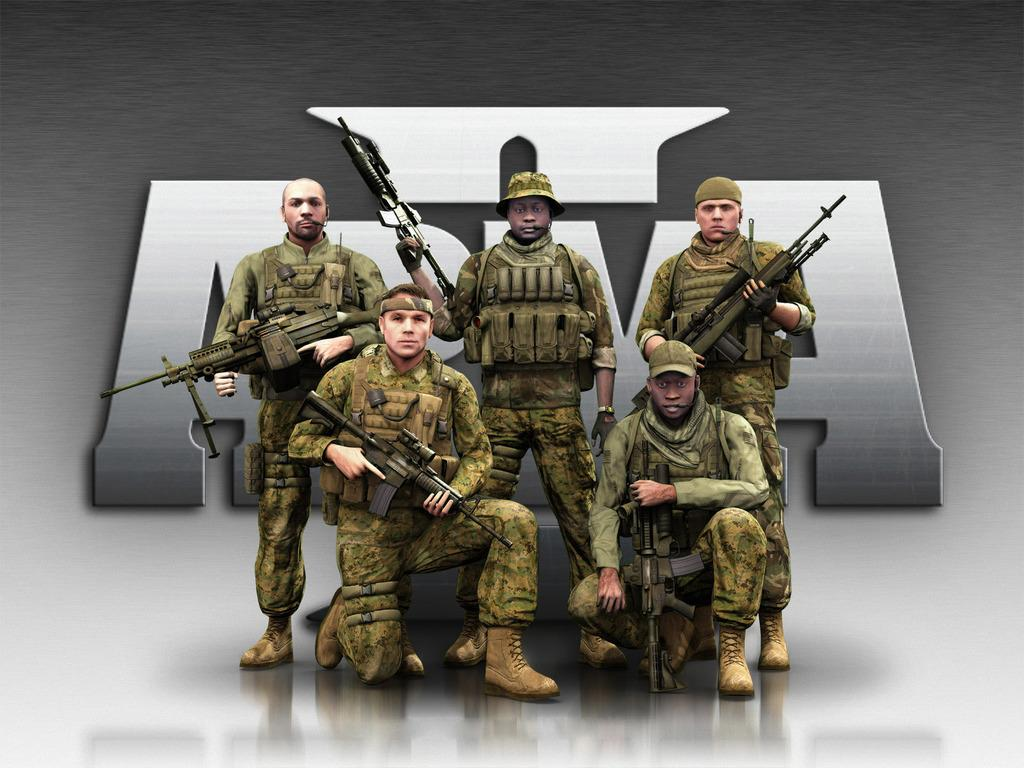What are the people in the image doing? Some people are standing, and some are sitting in the image. What are the people wearing? The people are wearing uniforms. What objects are the people holding in the image? The people are holding rifles. What can be seen in the background of the image? There is a board visible in the background of the image. What type of tin can be seen in the image? There is no tin present in the image. What month is depicted in the image? The image does not depict a specific month; it is a still photograph. 